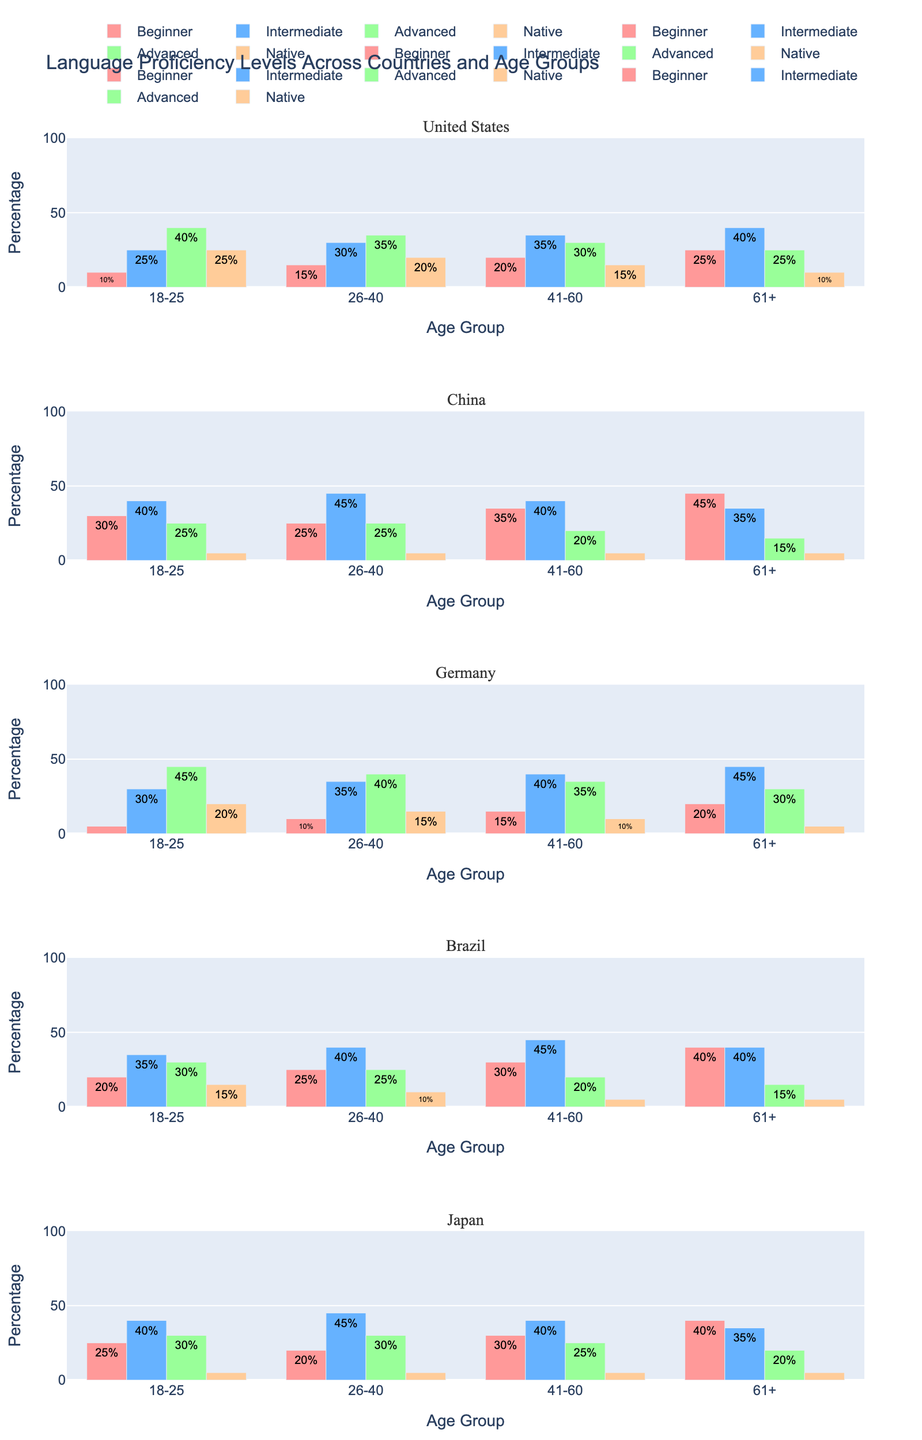What's the title of the figure? The title of the figure is displayed at the top and reads "AI Art Generation Processing Times".
Answer: AI Art Generation Processing Times Which subplots have the shortest and longest processing times for their algorithms? The shortest and longest processing times can be found in the y-axis values of each subplot. For "Stable Diffusion", the shortest processing time is 8 seconds (NVIDIA RTX 3090) and for "Imagen", the longest processing time is 40 seconds (NVIDIA GTX 1660).
Answer: Stable Diffusion (shortest: 8s), Imagen (longest: 40s) What is the difference in processing time between the NVIDIA RTX 3090 and NVIDIA GTX 1660 GPUs for the DALL-E 2 algorithm? The processing time for DALL-E 2 with NVIDIA RTX 3090 is 15 seconds and for NVIDIA GTX 1660 is 35 seconds. The difference is 35 - 15 = 20 seconds.
Answer: 20 seconds Which algorithm shows the most consistent processing times across different hardware configurations? Consistency can be assessed by looking at the range (difference between maximum and minimum values) of processing times for each algorithm across the subplots. "Stable Diffusion" has processing times of 8, 10, and 22 seconds, resulting in a range of 22 - 8 = 14 seconds, which is the smallest range compared to the other algorithms.
Answer: Stable Diffusion What is the average processing time for Midjourney across all hardware configurations? The processing times for Midjourney are 12, 14, and 28 seconds. The average is calculated as (12 + 14 + 28) / 3 ≈ 18 seconds.
Answer: 18 seconds Compare the processing times of the NVIDIA RTX 3080 GPU across all algorithms. Which algorithm has the lowest processing time with this GPU? Refer to the subplots and locate the bar corresponding to the NVIDIA RTX 3080 GPU within each one. The processing times are 18 seconds for DALL-E 2, 10 seconds for Stable Diffusion, 14 seconds for Midjourney, and 21 seconds for Imagen. The lowest processing time among them is 10 seconds for Stable Diffusion.
Answer: Stable Diffusion How much faster is the NVIDIA RTX 3090 compared to the NVIDIA GTX 1660 for generating art with the Imagen algorithm? The processing times for Imagen are 18 seconds (NVIDIA RTX 3090) and 40 seconds (NVIDIA GTX 1660). The difference in processing time is 40 - 18 = 22 seconds.
Answer: 22 seconds What's the combined processing time for generating artwork using all algorithms on an NVIDIA RTX 3090? Sum the processing times for NVIDIA RTX 3090 across all algorithms: 15 (DALL-E 2) + 8 (Stable Diffusion) + 12 (Midjourney) + 18 (Imagen) = 53 seconds.
Answer: 53 seconds Which GPU shows the highest variation in processing times across all algorithms? Variation can be determined by calculating the difference between the maximum and minimum processing times for each GPU across all algorithms. NVIDIA GTX 1660 has processing times of 35, 22, 28, and 40 seconds. The range for GTX 1660 is 40 - 22 = 18 seconds, which is the highest compared to the other GPUs.
Answer: NVIDIA GTX 1660 